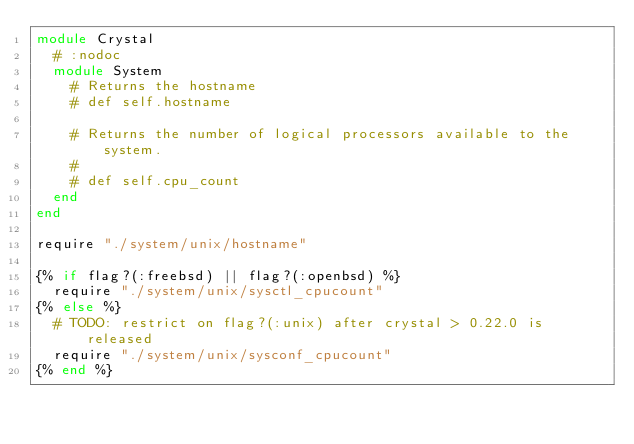Convert code to text. <code><loc_0><loc_0><loc_500><loc_500><_Crystal_>module Crystal
  # :nodoc
  module System
    # Returns the hostname
    # def self.hostname

    # Returns the number of logical processors available to the system.
    #
    # def self.cpu_count
  end
end

require "./system/unix/hostname"

{% if flag?(:freebsd) || flag?(:openbsd) %}
  require "./system/unix/sysctl_cpucount"
{% else %}
  # TODO: restrict on flag?(:unix) after crystal > 0.22.0 is released
  require "./system/unix/sysconf_cpucount"
{% end %}
</code> 